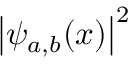Convert formula to latex. <formula><loc_0><loc_0><loc_500><loc_500>{ \left | \psi _ { a , b } ( x ) \right | } ^ { 2 }</formula> 